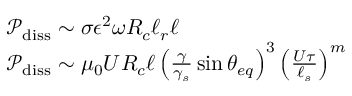<formula> <loc_0><loc_0><loc_500><loc_500>\begin{array} { r l } & { \mathcal { P } _ { d i s s } \sim \sigma \epsilon ^ { 2 } \omega R _ { c } \ell _ { r } \ell } \\ & { \mathcal { P } _ { d i s s } \sim \mu _ { 0 } U R _ { c } \ell \left ( \frac { \gamma } { \gamma _ { s } } \sin { \theta _ { e q } } \right ) ^ { 3 } \left ( \frac { U \tau } { \ell _ { s } } \right ) ^ { m } } \end{array}</formula> 